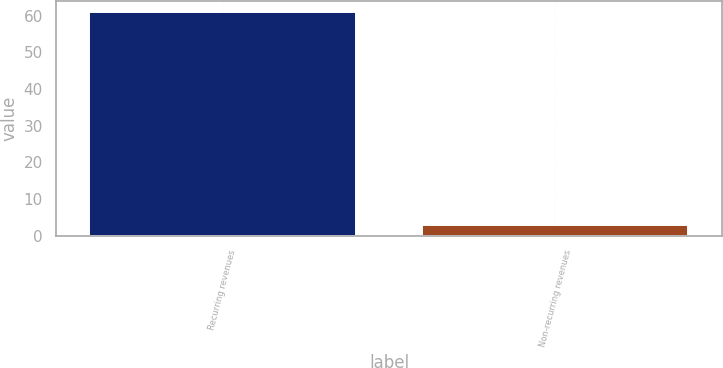<chart> <loc_0><loc_0><loc_500><loc_500><bar_chart><fcel>Recurring revenues<fcel>Non-recurring revenues<nl><fcel>61<fcel>3<nl></chart> 